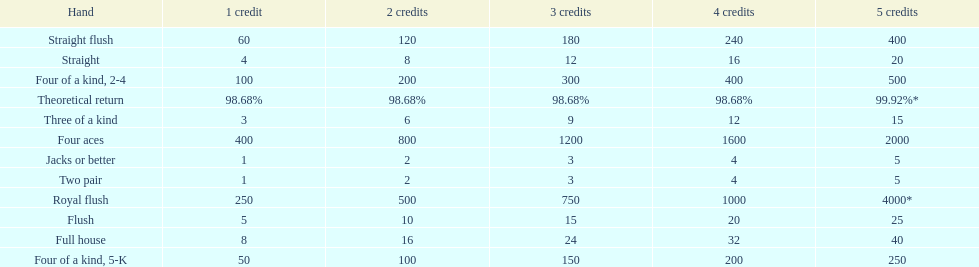What is the difference of payout on 3 credits, between a straight flush and royal flush? 570. 